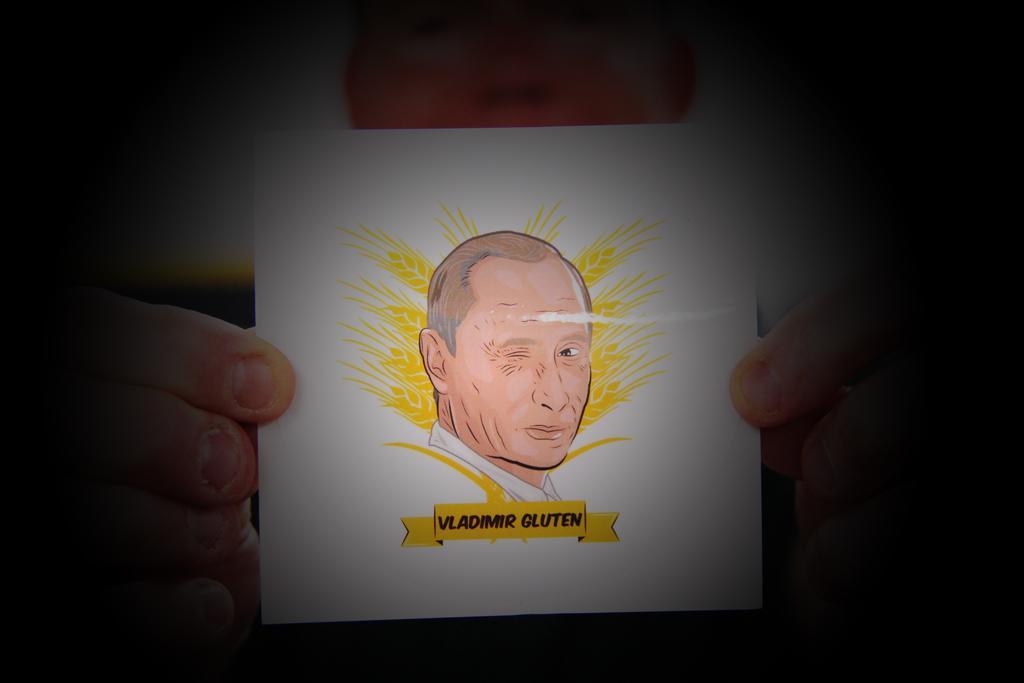In one or two sentences, can you explain what this image depicts? In the image a person is holding a sticker. 